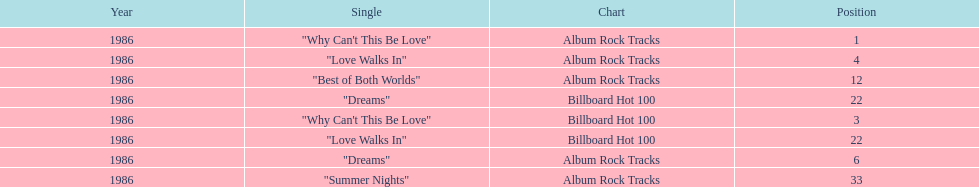Which is the most popular single on the album? Why Can't This Be Love. 